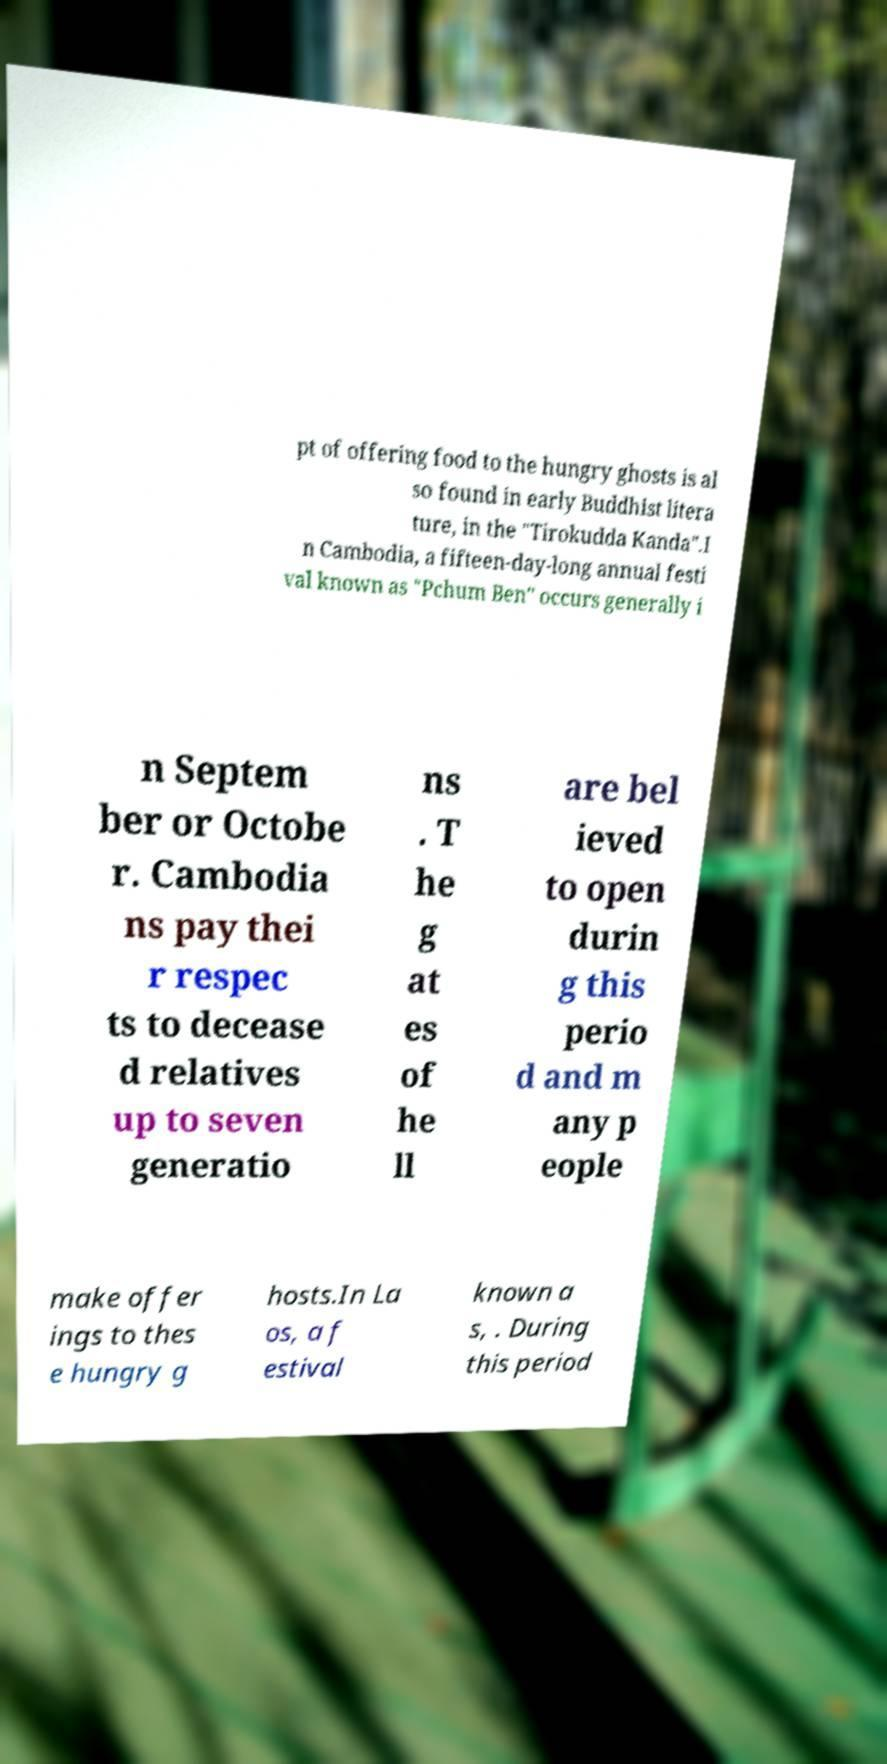Could you extract and type out the text from this image? pt of offering food to the hungry ghosts is al so found in early Buddhist litera ture, in the "Tirokudda Kanda".I n Cambodia, a fifteen-day-long annual festi val known as "Pchum Ben" occurs generally i n Septem ber or Octobe r. Cambodia ns pay thei r respec ts to decease d relatives up to seven generatio ns . T he g at es of he ll are bel ieved to open durin g this perio d and m any p eople make offer ings to thes e hungry g hosts.In La os, a f estival known a s, . During this period 